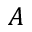<formula> <loc_0><loc_0><loc_500><loc_500>A</formula> 